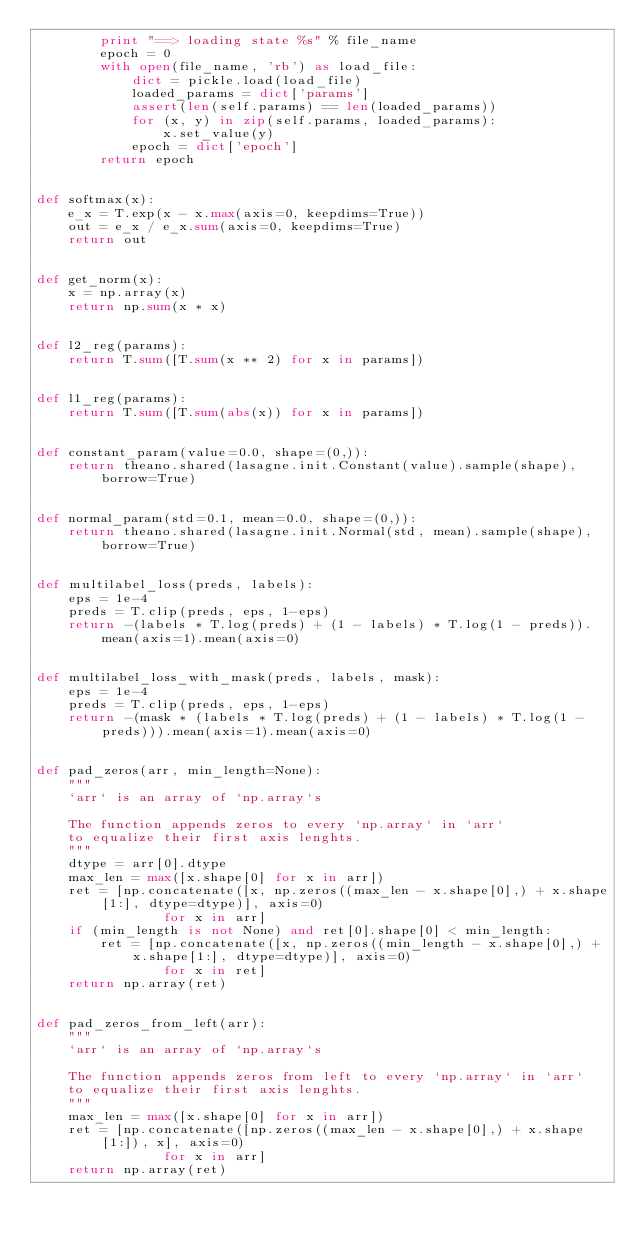<code> <loc_0><loc_0><loc_500><loc_500><_Python_>        print "==> loading state %s" % file_name
        epoch = 0
        with open(file_name, 'rb') as load_file:
            dict = pickle.load(load_file)
            loaded_params = dict['params']
            assert(len(self.params) == len(loaded_params))
            for (x, y) in zip(self.params, loaded_params):
                x.set_value(y)
            epoch = dict['epoch']
        return epoch


def softmax(x):
    e_x = T.exp(x - x.max(axis=0, keepdims=True))
    out = e_x / e_x.sum(axis=0, keepdims=True)
    return out


def get_norm(x):
    x = np.array(x)
    return np.sum(x * x)


def l2_reg(params):
    return T.sum([T.sum(x ** 2) for x in params])
    

def l1_reg(params):
    return T.sum([T.sum(abs(x)) for x in params])


def constant_param(value=0.0, shape=(0,)):
    return theano.shared(lasagne.init.Constant(value).sample(shape), borrow=True)
    

def normal_param(std=0.1, mean=0.0, shape=(0,)):
    return theano.shared(lasagne.init.Normal(std, mean).sample(shape), borrow=True)


def multilabel_loss(preds, labels):
    eps = 1e-4
    preds = T.clip(preds, eps, 1-eps)
    return -(labels * T.log(preds) + (1 - labels) * T.log(1 - preds)).mean(axis=1).mean(axis=0)


def multilabel_loss_with_mask(preds, labels, mask):
    eps = 1e-4
    preds = T.clip(preds, eps, 1-eps)
    return -(mask * (labels * T.log(preds) + (1 - labels) * T.log(1 - preds))).mean(axis=1).mean(axis=0)


def pad_zeros(arr, min_length=None):
    """
    `arr` is an array of `np.array`s
    
    The function appends zeros to every `np.array` in `arr`
    to equalize their first axis lenghts.
    """
    dtype = arr[0].dtype
    max_len = max([x.shape[0] for x in arr])
    ret = [np.concatenate([x, np.zeros((max_len - x.shape[0],) + x.shape[1:], dtype=dtype)], axis=0) 
                for x in arr]
    if (min_length is not None) and ret[0].shape[0] < min_length:
        ret = [np.concatenate([x, np.zeros((min_length - x.shape[0],) + x.shape[1:], dtype=dtype)], axis=0)
                for x in ret]
    return np.array(ret)
    

def pad_zeros_from_left(arr):
    """
    `arr` is an array of `np.array`s
    
    The function appends zeros from left to every `np.array` in `arr`
    to equalize their first axis lenghts.
    """
    max_len = max([x.shape[0] for x in arr])
    ret = [np.concatenate([np.zeros((max_len - x.shape[0],) + x.shape[1:]), x], axis=0) 
                for x in arr]
    return np.array(ret)
</code> 